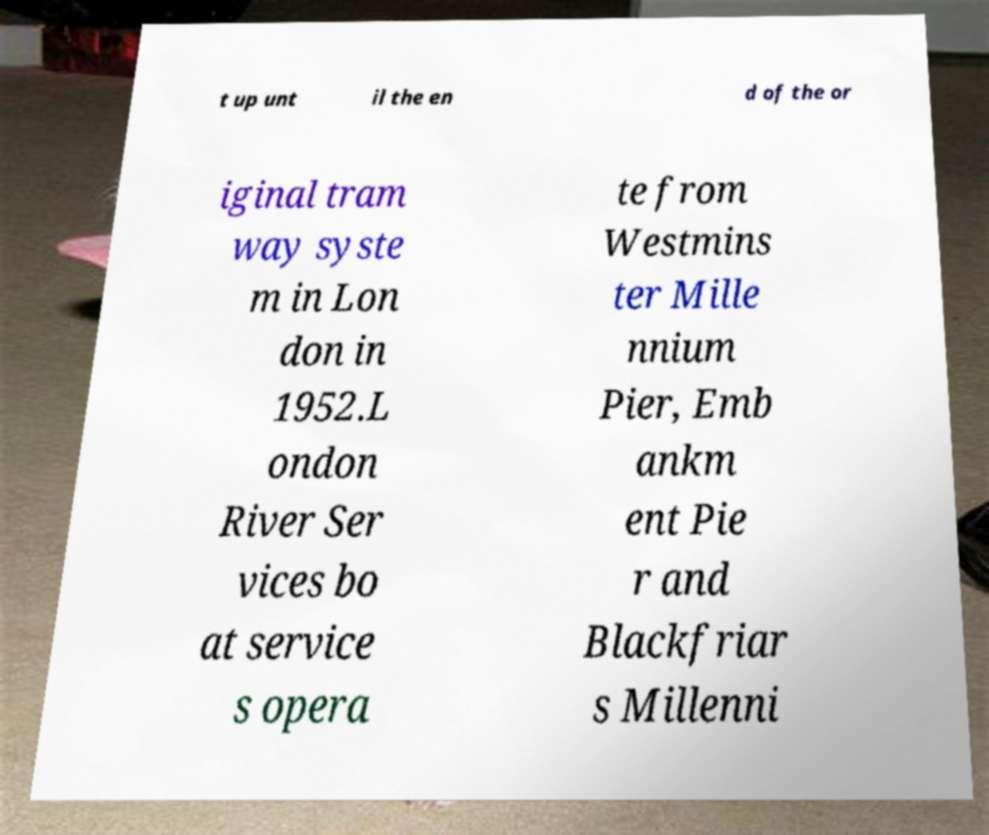There's text embedded in this image that I need extracted. Can you transcribe it verbatim? t up unt il the en d of the or iginal tram way syste m in Lon don in 1952.L ondon River Ser vices bo at service s opera te from Westmins ter Mille nnium Pier, Emb ankm ent Pie r and Blackfriar s Millenni 